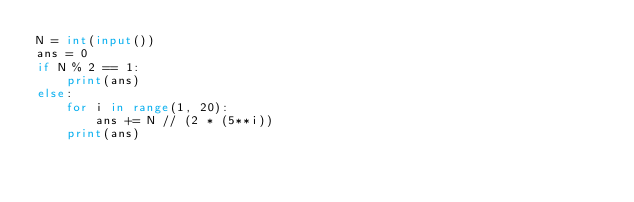<code> <loc_0><loc_0><loc_500><loc_500><_Python_>N = int(input())
ans = 0
if N % 2 == 1:
    print(ans)
else:
    for i in range(1, 20):
        ans += N // (2 * (5**i))
    print(ans)


</code> 